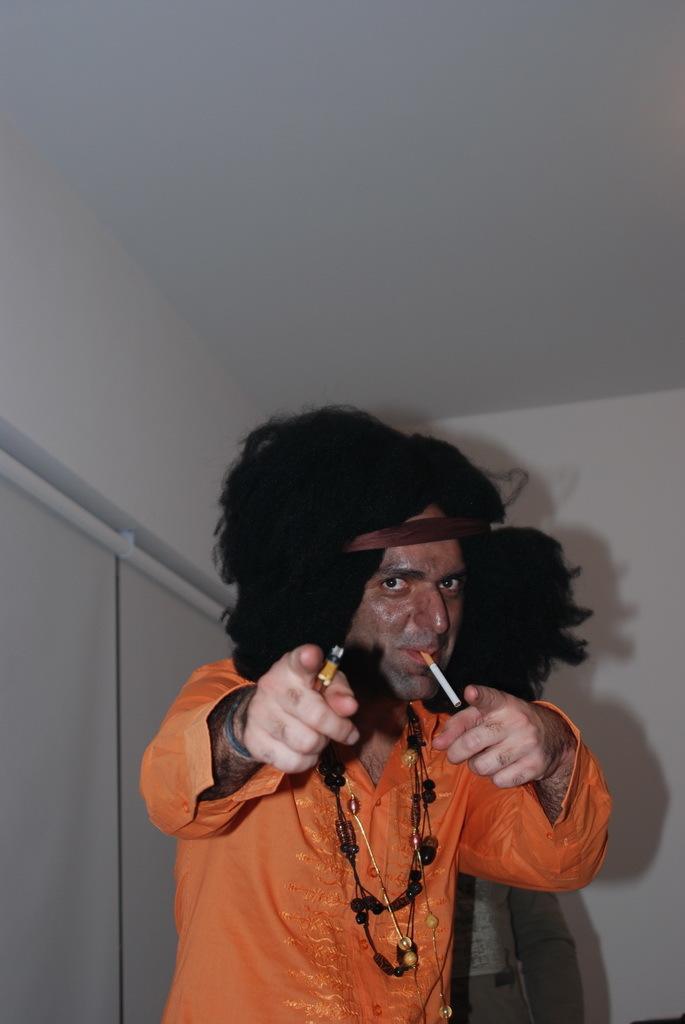Could you give a brief overview of what you see in this image? This picture might be taken inside the room. In this image, in the middle, we can see a man wearing an orange color shirt and holding something in his hand. In the background, we can see a wall. 